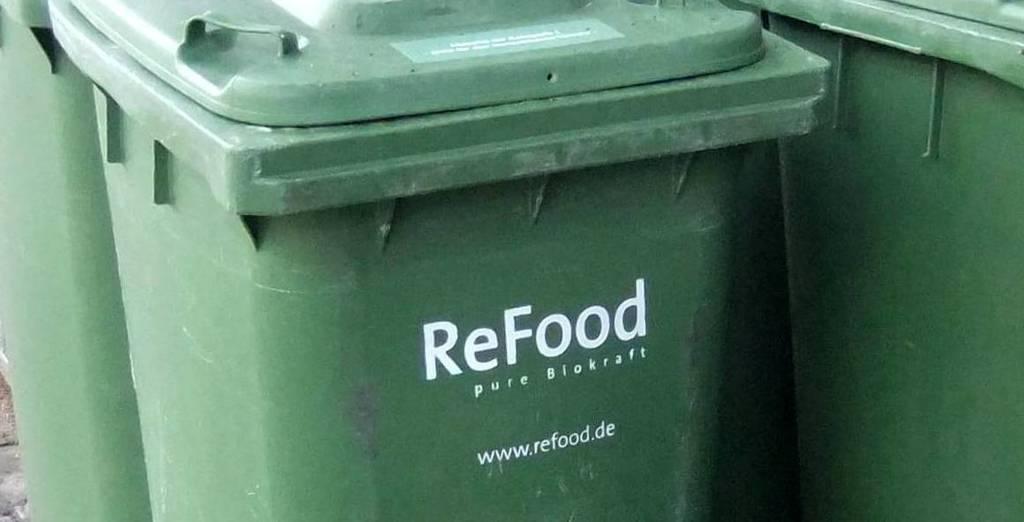What is the website link on this trash bin?
Ensure brevity in your answer.  Www.refood.de. What is the name on the can?
Your answer should be very brief. Refood. 